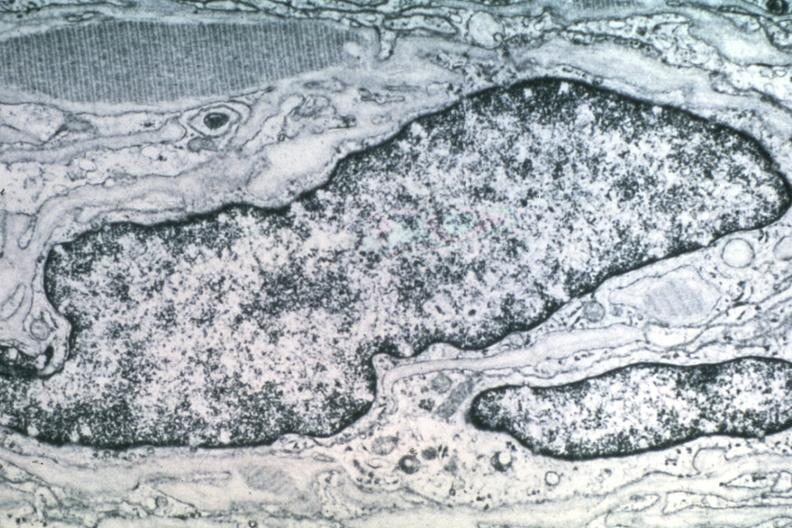s alpha smooth muscle actin immunohistochemical present?
Answer the question using a single word or phrase. No 